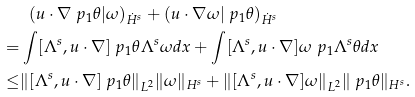<formula> <loc_0><loc_0><loc_500><loc_500>& \ \ ( u \cdot \nabla \ p _ { 1 } \theta | \omega ) _ { \dot { H } ^ { s } } + ( u \cdot \nabla \omega | \ p _ { 1 } \theta ) _ { \dot { H } ^ { s } } \\ = & \int [ \Lambda ^ { s } , u \cdot \nabla ] \ p _ { 1 } \theta \Lambda ^ { s } \omega d x + \int [ \Lambda ^ { s } , u \cdot \nabla ] \omega \ p _ { 1 } \Lambda ^ { s } \theta d x \\ \leq & \| [ \Lambda ^ { s } , u \cdot \nabla ] \ p _ { 1 } \theta \| _ { L ^ { 2 } } \| \omega \| _ { H ^ { s } } + \| [ \Lambda ^ { s } , u \cdot \nabla ] \omega \| _ { L ^ { 2 } } \| \ p _ { 1 } \theta \| _ { H ^ { s } } .</formula> 